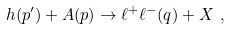Convert formula to latex. <formula><loc_0><loc_0><loc_500><loc_500>h ( p ^ { \prime } ) + A ( p ) \rightarrow \ell ^ { + } \ell ^ { - } ( q ) + X \ ,</formula> 